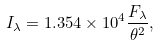<formula> <loc_0><loc_0><loc_500><loc_500>I _ { \lambda } = 1 . 3 5 4 \times 1 0 ^ { 4 } \frac { F _ { \lambda } } { { \theta } ^ { 2 } } ,</formula> 